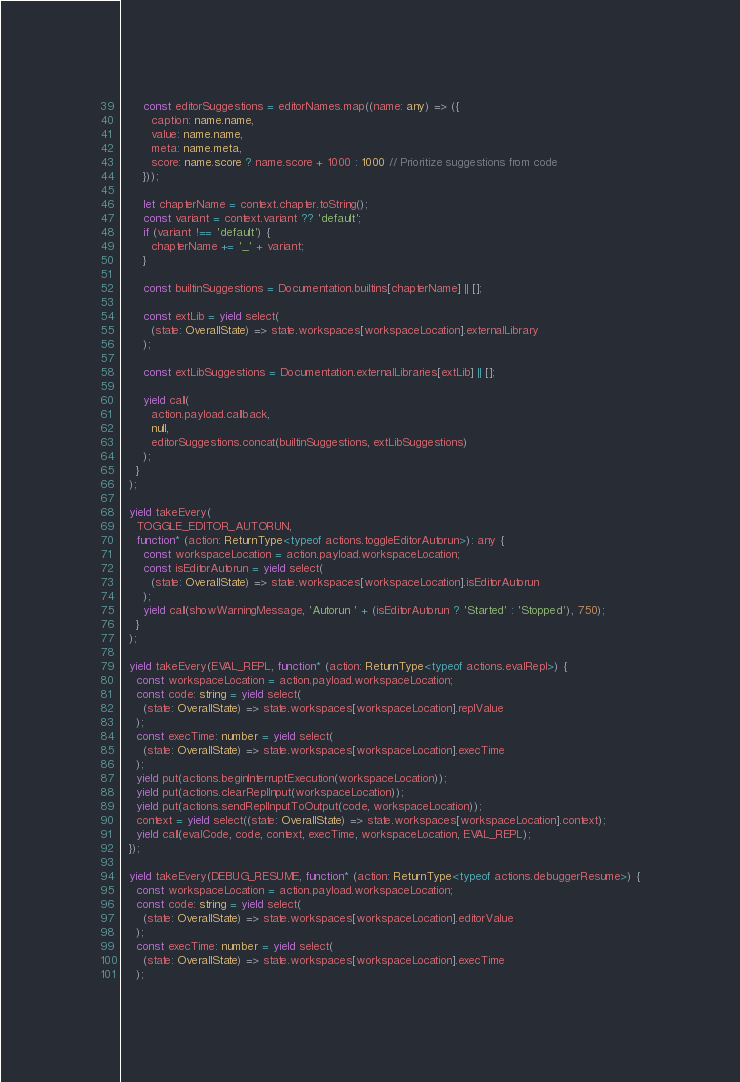Convert code to text. <code><loc_0><loc_0><loc_500><loc_500><_TypeScript_>      const editorSuggestions = editorNames.map((name: any) => ({
        caption: name.name,
        value: name.name,
        meta: name.meta,
        score: name.score ? name.score + 1000 : 1000 // Prioritize suggestions from code
      }));

      let chapterName = context.chapter.toString();
      const variant = context.variant ?? 'default';
      if (variant !== 'default') {
        chapterName += '_' + variant;
      }

      const builtinSuggestions = Documentation.builtins[chapterName] || [];

      const extLib = yield select(
        (state: OverallState) => state.workspaces[workspaceLocation].externalLibrary
      );

      const extLibSuggestions = Documentation.externalLibraries[extLib] || [];

      yield call(
        action.payload.callback,
        null,
        editorSuggestions.concat(builtinSuggestions, extLibSuggestions)
      );
    }
  );

  yield takeEvery(
    TOGGLE_EDITOR_AUTORUN,
    function* (action: ReturnType<typeof actions.toggleEditorAutorun>): any {
      const workspaceLocation = action.payload.workspaceLocation;
      const isEditorAutorun = yield select(
        (state: OverallState) => state.workspaces[workspaceLocation].isEditorAutorun
      );
      yield call(showWarningMessage, 'Autorun ' + (isEditorAutorun ? 'Started' : 'Stopped'), 750);
    }
  );

  yield takeEvery(EVAL_REPL, function* (action: ReturnType<typeof actions.evalRepl>) {
    const workspaceLocation = action.payload.workspaceLocation;
    const code: string = yield select(
      (state: OverallState) => state.workspaces[workspaceLocation].replValue
    );
    const execTime: number = yield select(
      (state: OverallState) => state.workspaces[workspaceLocation].execTime
    );
    yield put(actions.beginInterruptExecution(workspaceLocation));
    yield put(actions.clearReplInput(workspaceLocation));
    yield put(actions.sendReplInputToOutput(code, workspaceLocation));
    context = yield select((state: OverallState) => state.workspaces[workspaceLocation].context);
    yield call(evalCode, code, context, execTime, workspaceLocation, EVAL_REPL);
  });

  yield takeEvery(DEBUG_RESUME, function* (action: ReturnType<typeof actions.debuggerResume>) {
    const workspaceLocation = action.payload.workspaceLocation;
    const code: string = yield select(
      (state: OverallState) => state.workspaces[workspaceLocation].editorValue
    );
    const execTime: number = yield select(
      (state: OverallState) => state.workspaces[workspaceLocation].execTime
    );</code> 